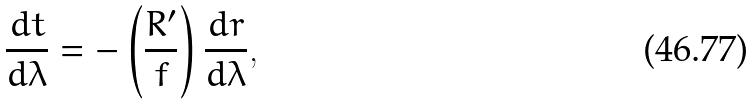Convert formula to latex. <formula><loc_0><loc_0><loc_500><loc_500>\frac { d t } { d \lambda } = - \left ( \frac { R ^ { \prime } } { f } \right ) \frac { d r } { d \lambda } ,</formula> 